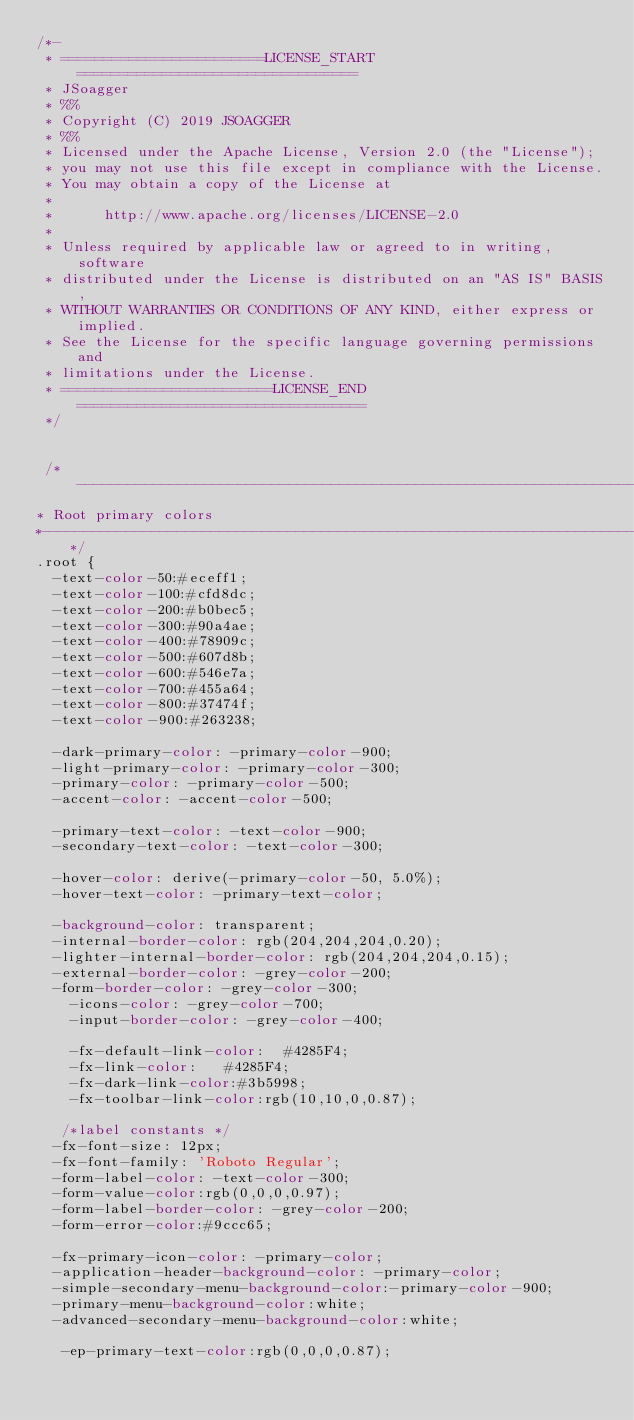<code> <loc_0><loc_0><loc_500><loc_500><_CSS_>/*-
 * ========================LICENSE_START=================================
 * JSoagger 
 * %%
 * Copyright (C) 2019 JSOAGGER
 * %%
 * Licensed under the Apache License, Version 2.0 (the "License");
 * you may not use this file except in compliance with the License.
 * You may obtain a copy of the License at
 * 
 *      http://www.apache.org/licenses/LICENSE-2.0
 * 
 * Unless required by applicable law or agreed to in writing, software
 * distributed under the License is distributed on an "AS IS" BASIS,
 * WITHOUT WARRANTIES OR CONDITIONS OF ANY KIND, either express or implied.
 * See the License for the specific language governing permissions and
 * limitations under the License.
 * =========================LICENSE_END==================================
 */

 
 /*--------------------------------------------------------------------------------------------------------------------------------
* Root primary colors
*--------------------------------------------------------------------------------------------------------------------------------*/
.root {
	-text-color-50:#eceff1;
	-text-color-100:#cfd8dc;
	-text-color-200:#b0bec5;
	-text-color-300:#90a4ae;
	-text-color-400:#78909c;
	-text-color-500:#607d8b;
	-text-color-600:#546e7a;
	-text-color-700:#455a64;
	-text-color-800:#37474f;
	-text-color-900:#263238;
	
	-dark-primary-color: -primary-color-900;
	-light-primary-color: -primary-color-300;
	-primary-color: -primary-color-500;
	-accent-color: -accent-color-500;
	
	-primary-text-color: -text-color-900;
	-secondary-text-color: -text-color-300;
	
	-hover-color: derive(-primary-color-50, 5.0%);
	-hover-text-color: -primary-text-color;
	
	-background-color: transparent;
	-internal-border-color: rgb(204,204,204,0.20);
	-lighter-internal-border-color: rgb(204,204,204,0.15);
	-external-border-color: -grey-color-200;
	-form-border-color: -grey-color-300;
    -icons-color: -grey-color-700;
    -input-border-color: -grey-color-400;
    
    -fx-default-link-color:  #4285F4;
    -fx-link-color:   #4285F4;
    -fx-dark-link-color:#3b5998;
    -fx-toolbar-link-color:rgb(10,10,0,0.87);
	
	 /*label constants */
	-fx-font-size: 12px;
	-fx-font-family: 'Roboto Regular';
	-form-label-color: -text-color-300;
	-form-value-color:rgb(0,0,0,0.97);
	-form-label-border-color: -grey-color-200;
	-form-error-color:#9ccc65;
	
	-fx-primary-icon-color: -primary-color;
	-application-header-background-color: -primary-color;
	-simple-secondary-menu-background-color:-primary-color-900;
	-primary-menu-background-color:white;
	-advanced-secondary-menu-background-color:white;
	 
	 -ep-primary-text-color:rgb(0,0,0,0.87);</code> 